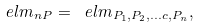Convert formula to latex. <formula><loc_0><loc_0><loc_500><loc_500>\ e l m _ { n P } = \ e l m _ { P _ { 1 } , P _ { 2 } , \dots c , P _ { n } } ,</formula> 